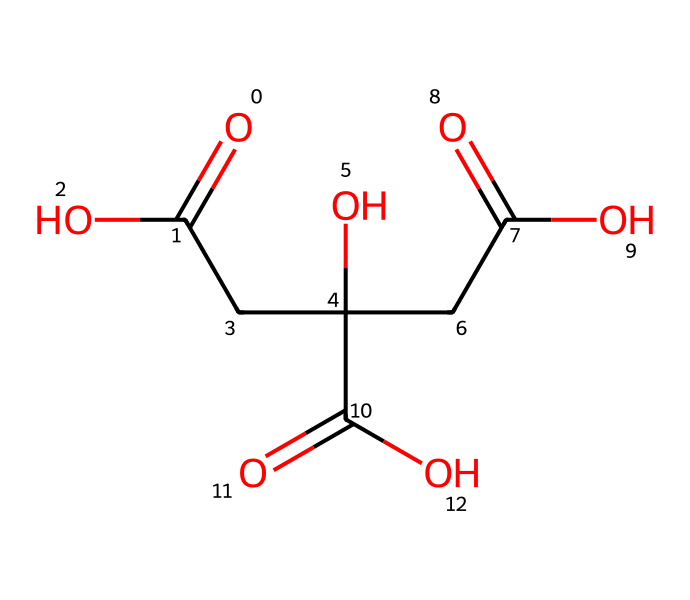What is the chemical name of this molecule? The SMILES representation corresponds to a compound with the structure indicating three carboxylic acid functional groups (–COOH), which identifies it as citric acid.
Answer: citric acid How many carboxylic acid groups are present in this molecule? By examining the structure, there are three instances of the carboxylic acid functional group (–COOH), which are key to determining the acidity.
Answer: three What is the molecular weight of citric acid? The molecular weight can be calculated using the atomic weights of carbon, hydrogen, and oxygen present in the structure. For citric acid, the total comes to about 192.13 g/mol.
Answer: 192.13 How many oxygen atoms are in the structure? Counting the oxygen atoms in the SMILES representation yields four oxygen atoms in total, present within the carboxylic acid groups.
Answer: four What type of compound is citric acid? Citric acid contains multiple acidic groups and exhibits properties typical of acids, classified specifically as a weak organic acid due to its dissociation in water.
Answer: weak organic acid How does the structure of citric acid affect its taste? The presence of the three carboxylic acid groups contributes to its sour flavor, commonly associated with fruit, which children enjoy.
Answer: sour Can citric acid act as a buffer? The three acidic protons in citric acid can donate or accept protons, allowing it to help maintain pH levels, functioning as a buffer in biological systems.
Answer: yes 